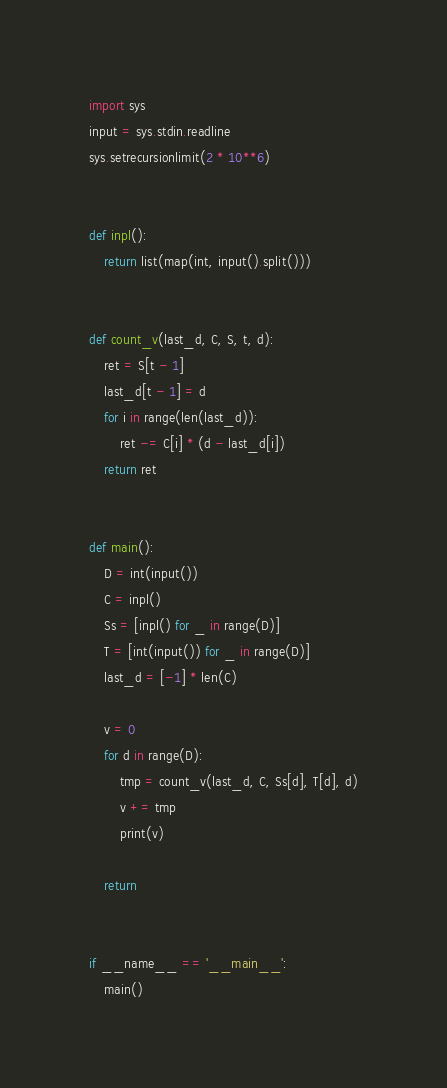Convert code to text. <code><loc_0><loc_0><loc_500><loc_500><_Python_>import sys
input = sys.stdin.readline
sys.setrecursionlimit(2 * 10**6)


def inpl():
    return list(map(int, input().split()))


def count_v(last_d, C, S, t, d):
    ret = S[t - 1]
    last_d[t - 1] = d
    for i in range(len(last_d)):
        ret -= C[i] * (d - last_d[i])
    return ret


def main():
    D = int(input())
    C = inpl()
    Ss = [inpl() for _ in range(D)]
    T = [int(input()) for _ in range(D)]
    last_d = [-1] * len(C)

    v = 0
    for d in range(D):
        tmp = count_v(last_d, C, Ss[d], T[d], d)
        v += tmp
        print(v)

    return


if __name__ == '__main__':
    main()
</code> 